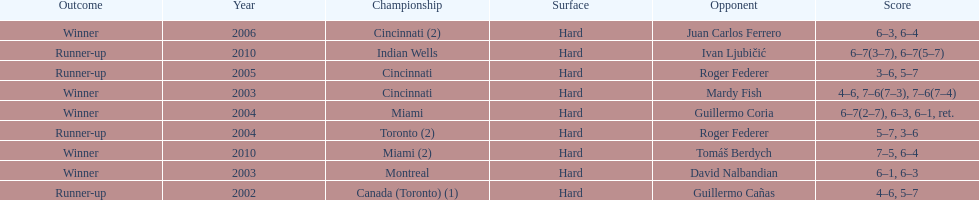How many championships occurred in toronto or montreal? 3. 